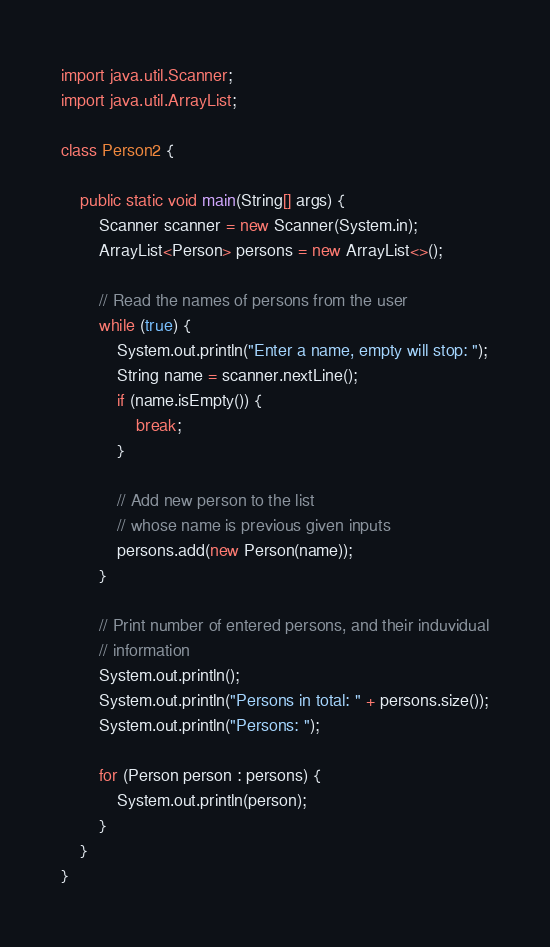Convert code to text. <code><loc_0><loc_0><loc_500><loc_500><_Java_>import java.util.Scanner;
import java.util.ArrayList;

class Person2 {

	public static void main(String[] args) {
		Scanner scanner = new Scanner(System.in);
		ArrayList<Person> persons = new ArrayList<>();

		// Read the names of persons from the user
		while (true) {
			System.out.println("Enter a name, empty will stop: ");
			String name = scanner.nextLine();
			if (name.isEmpty()) {
				break;
			}

			// Add new person to the list
			// whose name is previous given inputs
			persons.add(new Person(name));
		}

		// Print number of entered persons, and their induvidual
		// information
		System.out.println();
		System.out.println("Persons in total: " + persons.size());
		System.out.println("Persons: ");

		for (Person person : persons) {
			System.out.println(person);
		}
	}
}
</code> 